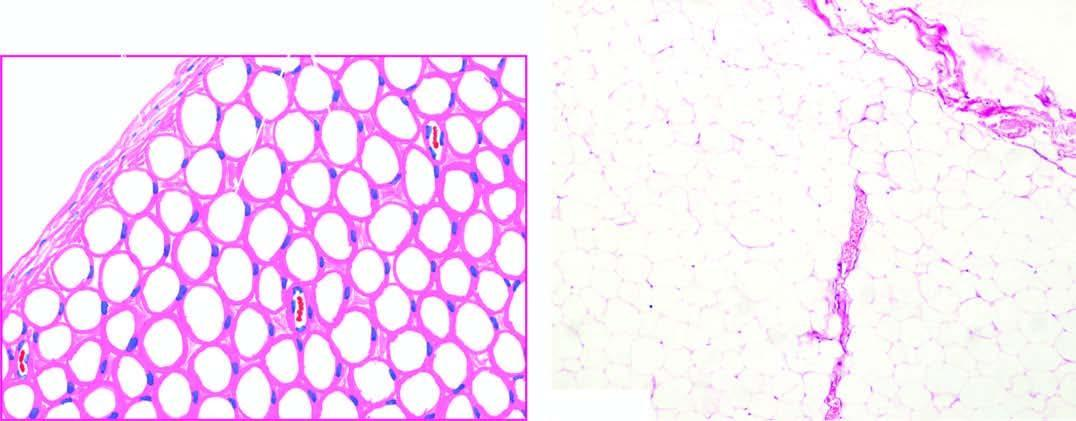does a wedge-shaped shrunken area of pale colour show a thin capsule and underlying lobules of mature adipose cells separated by delicate fibrous septa?
Answer the question using a single word or phrase. No 